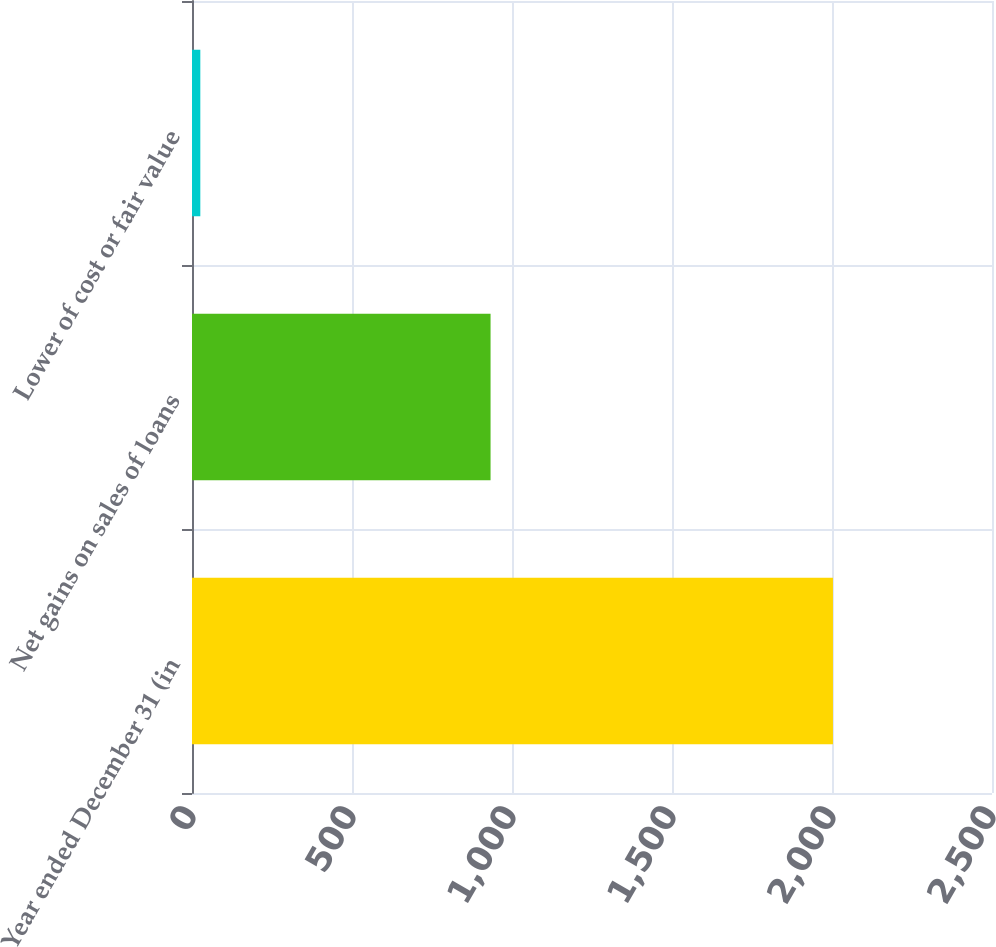<chart> <loc_0><loc_0><loc_500><loc_500><bar_chart><fcel>Year ended December 31 (in<fcel>Net gains on sales of loans<fcel>Lower of cost or fair value<nl><fcel>2003<fcel>933<fcel>26<nl></chart> 